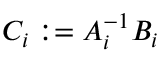Convert formula to latex. <formula><loc_0><loc_0><loc_500><loc_500>C _ { i } \colon = A _ { i } ^ { - 1 } B _ { i }</formula> 